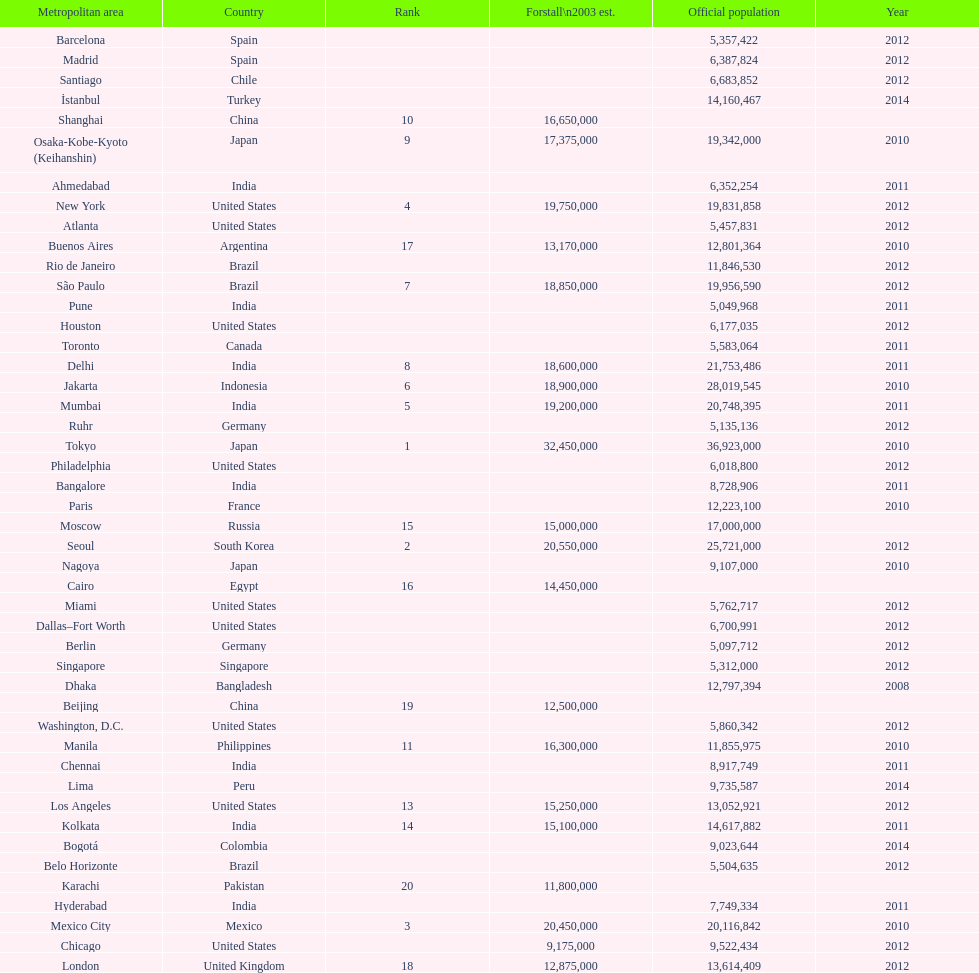Which place is referred to prior to chicago? Chennai. 